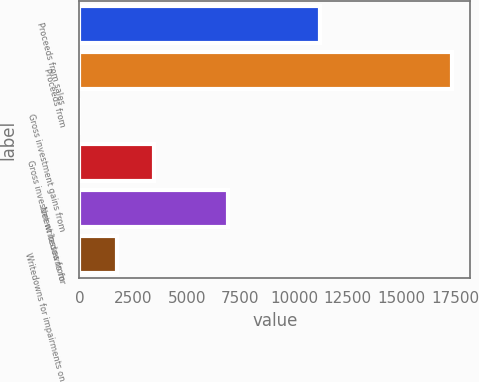Convert chart to OTSL. <chart><loc_0><loc_0><loc_500><loc_500><bar_chart><fcel>Proceeds from sales<fcel>Proceeds from<fcel>Gross investment gains from<fcel>Gross investment losses from<fcel>Net writedowns for<fcel>Writedowns for impairments on<nl><fcel>11214<fcel>17346<fcel>3.18<fcel>3471.74<fcel>6940.3<fcel>1737.46<nl></chart> 